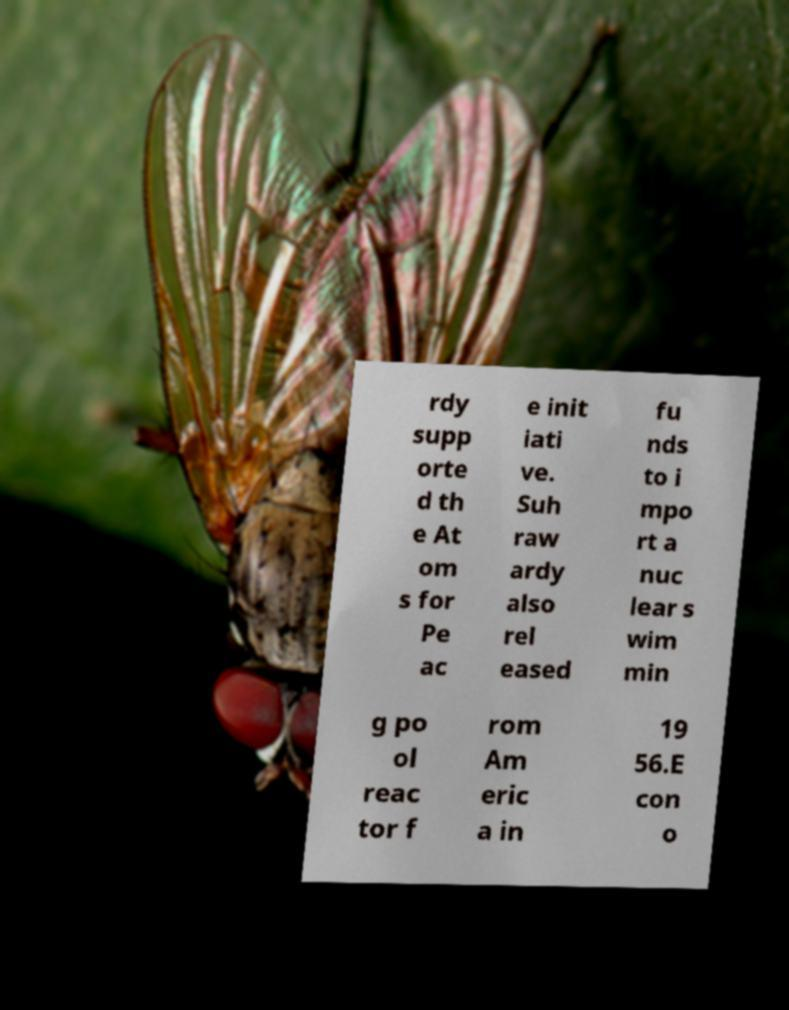Please identify and transcribe the text found in this image. rdy supp orte d th e At om s for Pe ac e init iati ve. Suh raw ardy also rel eased fu nds to i mpo rt a nuc lear s wim min g po ol reac tor f rom Am eric a in 19 56.E con o 